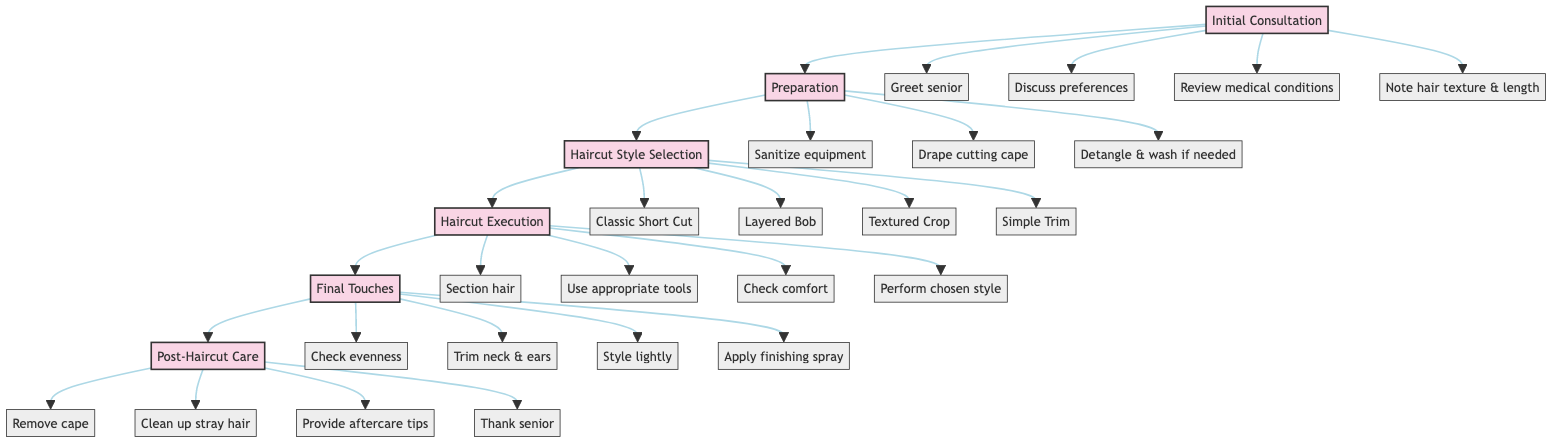What is the first step in the haircut workflow? The first step in the diagram is labeled as "Initial Consultation." This is indicated at the beginning of the flowchart before any other steps.
Answer: Initial Consultation How many main steps are there in the haircut workflow? The diagram outlines six main steps, which are Initial Consultation, Preparation, Haircut Style Selection, Haircut Execution, Final Touches, and Post-Haircut Care. Each one is represented as a distinct node along the flow.
Answer: Six Which step comes after 'Preparation'? The step that follows 'Preparation' is 'Haircut Style Selection'. This can be determined by following the flow from 'Preparation' to the next connected node.
Answer: Haircut Style Selection What action is included in the ‘Final Touches’ step? In the 'Final Touches' step, the action "Check for evenness" is included. This action is listed among the tasks to be performed in this specific node of the flowchart.
Answer: Check for evenness What actions are performed during the 'Haircut Execution' step? The actions in the 'Haircut Execution' step include: "Begin with sectioning the hair", "Use appropriate shears or clippers", "Constantly check for senior’s comfort", and "Perform the chosen haircut style". To identify all actions, you examine the connections from the 'Haircut Execution' node and list all related actions.
Answer: Section hair, Use appropriate tools, Check comfort, Perform chosen style At which step do you provide aftercare tips? Aftercare tips are provided during the 'Post-Haircut Care' step. This step is the last in the workflow, and the action is clearly stated in the node that follows 'Final Touches'.
Answer: Post-Haircut Care What is the action before 'Haircut Style Selection'? The action immediately before 'Haircut Style Selection' is 'Preparation'. This can be seen by reviewing the flow from 'Preparation' directly leading into 'Haircut Style Selection'.
Answer: Preparation How are actions categorized in this diagram? The actions in the diagram are categorized into specific steps, with each step containing a list of related actions. Individual actions are connected to their respective step nodes, emphasizing their association.
Answer: Steps with related actions 